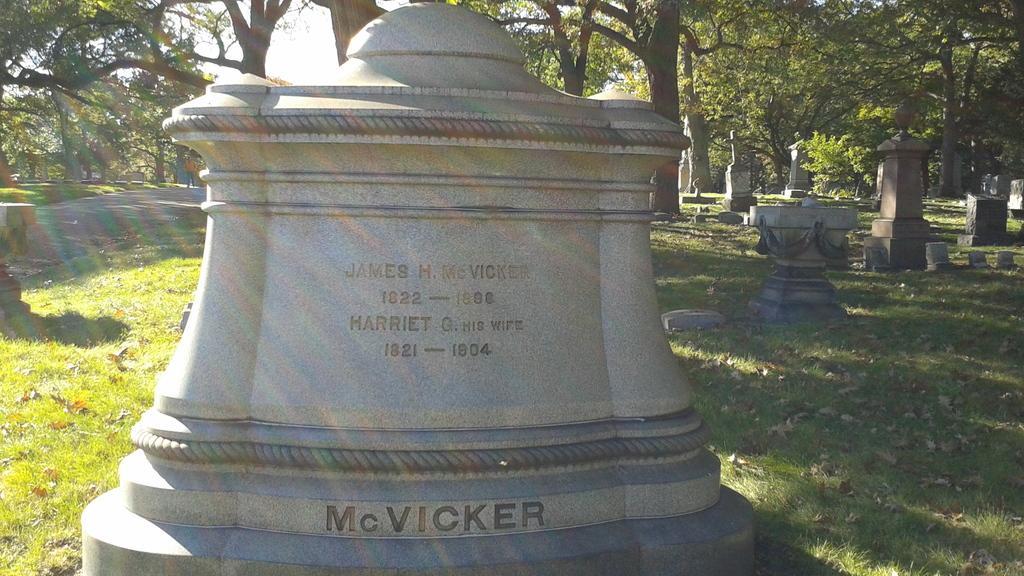In one or two sentences, can you explain what this image depicts? There is a head stone which has something written on it and there are few other headstones in the right corner and there are trees in the background. 